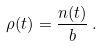Convert formula to latex. <formula><loc_0><loc_0><loc_500><loc_500>\rho ( t ) = \frac { n ( t ) } { b } \, .</formula> 